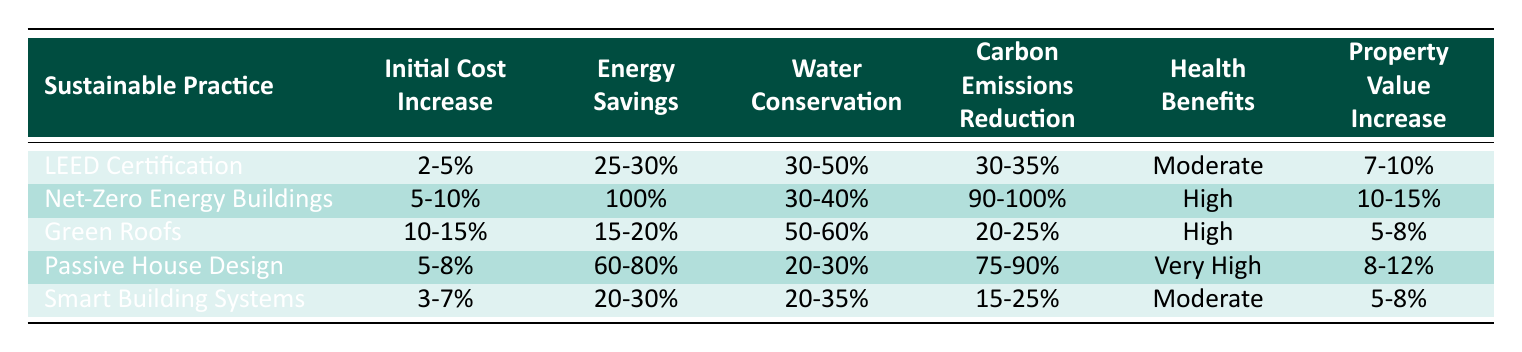What is the initial cost increase percentage range for Passive House Design? The initial cost increase percentage for Passive House Design is provided in the second column of the table. It states a range of 5-8%.
Answer: 5-8% Which sustainable practice has the highest energy savings percentage? The table shows that Net-Zero Energy Buildings have energy savings of 100%, which is the highest compared to the other practices.
Answer: Net-Zero Energy Buildings Is the health benefit level for Smart Building Systems moderate? Referring to the health benefits column in the table, Smart Building Systems indeed have a health benefit level labeled as "Moderate."
Answer: Yes What is the average property value increase percentage for Green Roofs and Smart Building Systems? The property value increase for Green Roofs is 5-8% and for Smart Building Systems is also 5-8%. To find the average, we can take the mid-range of each: (5 + 8)/2 = 6.5 for both. Thus, the average is (6.5 + 6.5) / 2 = 6.5%.
Answer: 6.5% Which two building practices have the highest reduction in carbon emissions? The table lists the carbon emissions reduction for each practice. Net-Zero Energy Buildings have a reduction of 90-100%, and Passive House Design ranges from 75-90%. Net-Zero Energy Buildings and Passive House Design are thus the top two practices for carbon emissions reduction.
Answer: Net-Zero Energy Buildings and Passive House Design How much more is the initial cost increase of Green Roofs compared to Smart Building Systems? From the table, Green Roofs have an initial cost increase of 10-15%, whereas Smart Building Systems have 3-7%. Taking the average of both ranges gives us a difference: for Green Roofs, (10+15)/2 = 12.5%, and for Smart Building Systems, (3+7)/2 = 5%. Therefore, the difference is: 12.5 - 5 = 7.5%.
Answer: 7.5% Is it true that all sustainable practices listed lead to water conservation? All practices must have a specific percentage for water conservation listed in the corresponding column; the table shows that each practice has a value, confirming they all contribute to water conservation.
Answer: Yes Which practice offers the least increase in property value? The property value increase percentages are listed in the last column. Green Roofs have the lowest increase at 5-8% compared to the others.
Answer: Green Roofs 